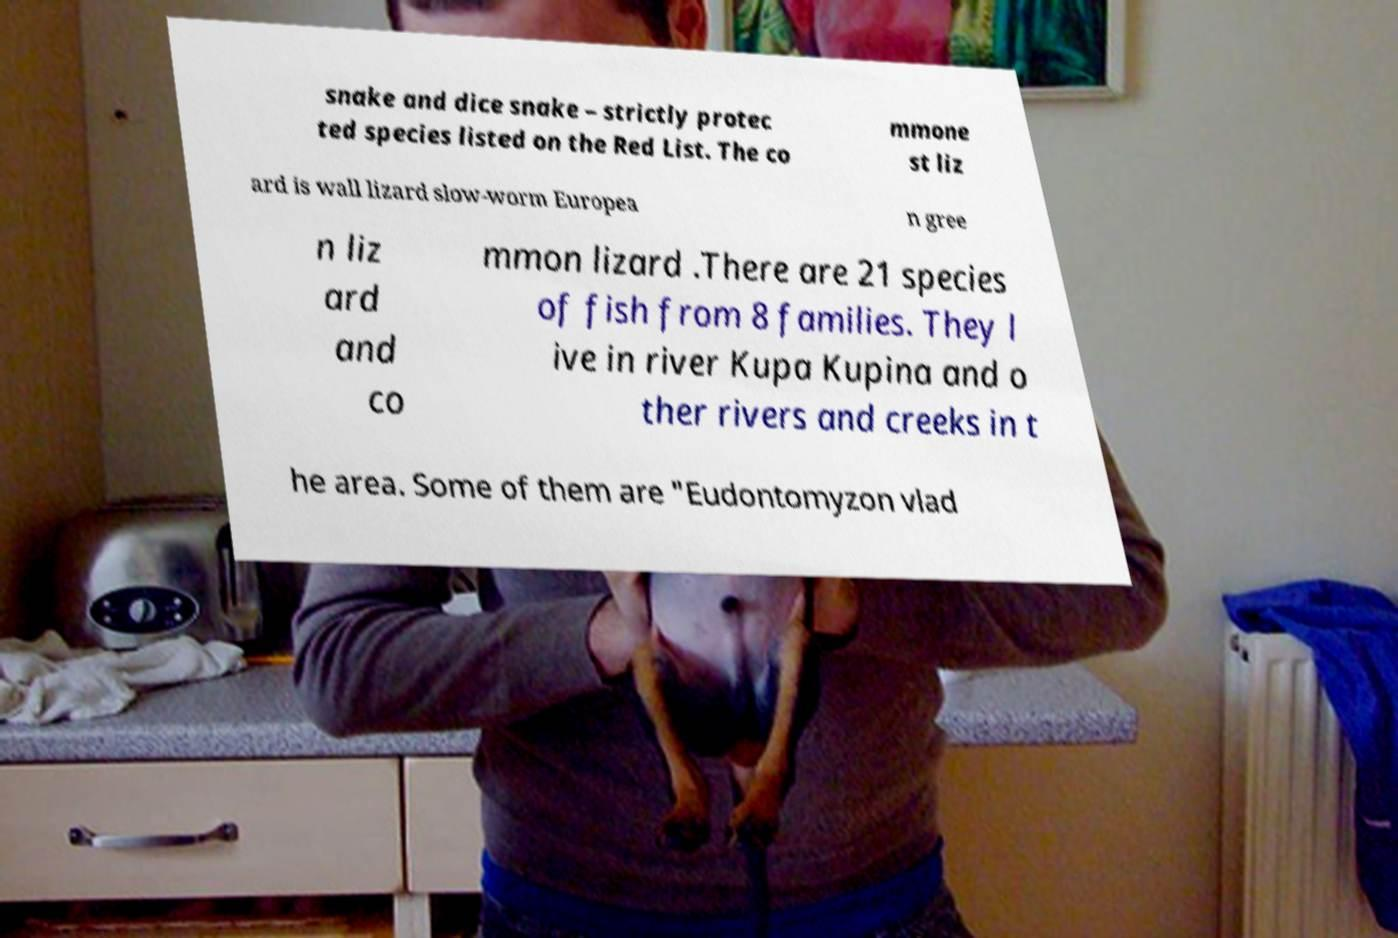Please read and relay the text visible in this image. What does it say? snake and dice snake – strictly protec ted species listed on the Red List. The co mmone st liz ard is wall lizard slow-worm Europea n gree n liz ard and co mmon lizard .There are 21 species of fish from 8 families. They l ive in river Kupa Kupina and o ther rivers and creeks in t he area. Some of them are "Eudontomyzon vlad 